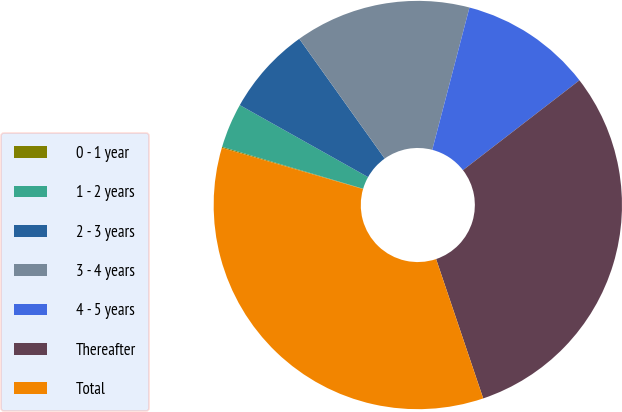Convert chart. <chart><loc_0><loc_0><loc_500><loc_500><pie_chart><fcel>0 - 1 year<fcel>1 - 2 years<fcel>2 - 3 years<fcel>3 - 4 years<fcel>4 - 5 years<fcel>Thereafter<fcel>Total<nl><fcel>0.08%<fcel>3.54%<fcel>7.0%<fcel>13.93%<fcel>10.47%<fcel>30.27%<fcel>34.71%<nl></chart> 